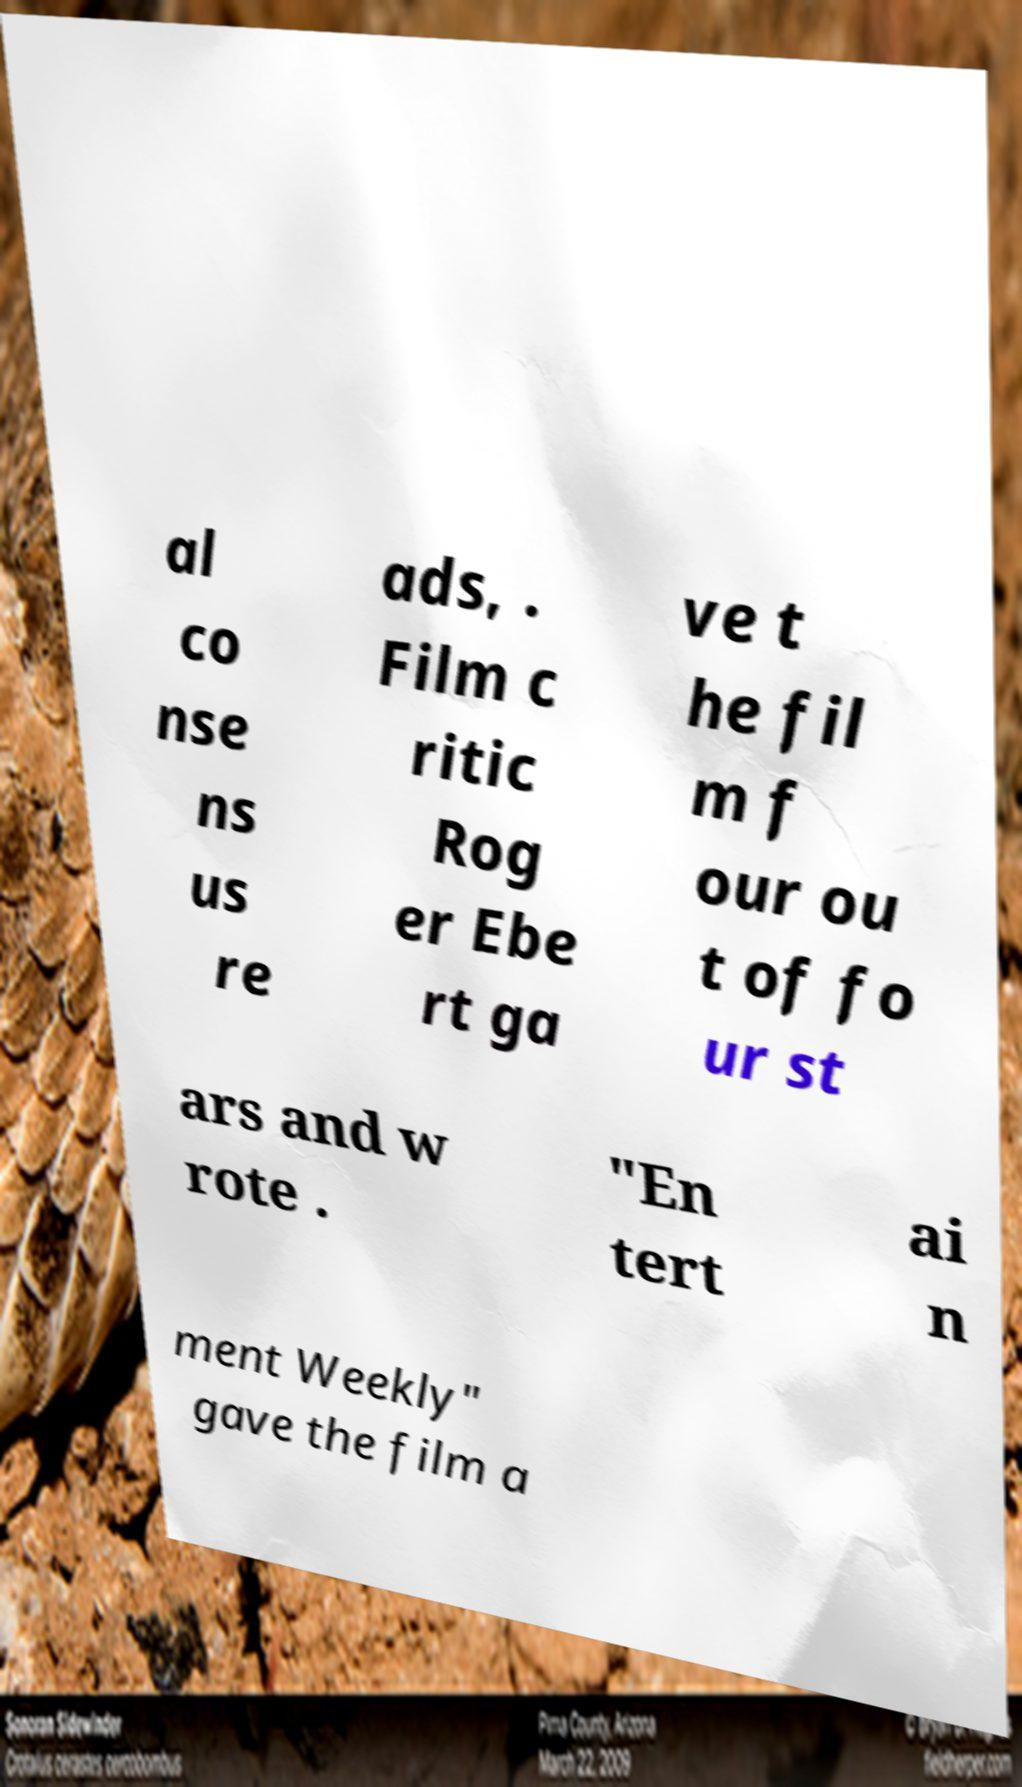There's text embedded in this image that I need extracted. Can you transcribe it verbatim? al co nse ns us re ads, . Film c ritic Rog er Ebe rt ga ve t he fil m f our ou t of fo ur st ars and w rote . "En tert ai n ment Weekly" gave the film a 